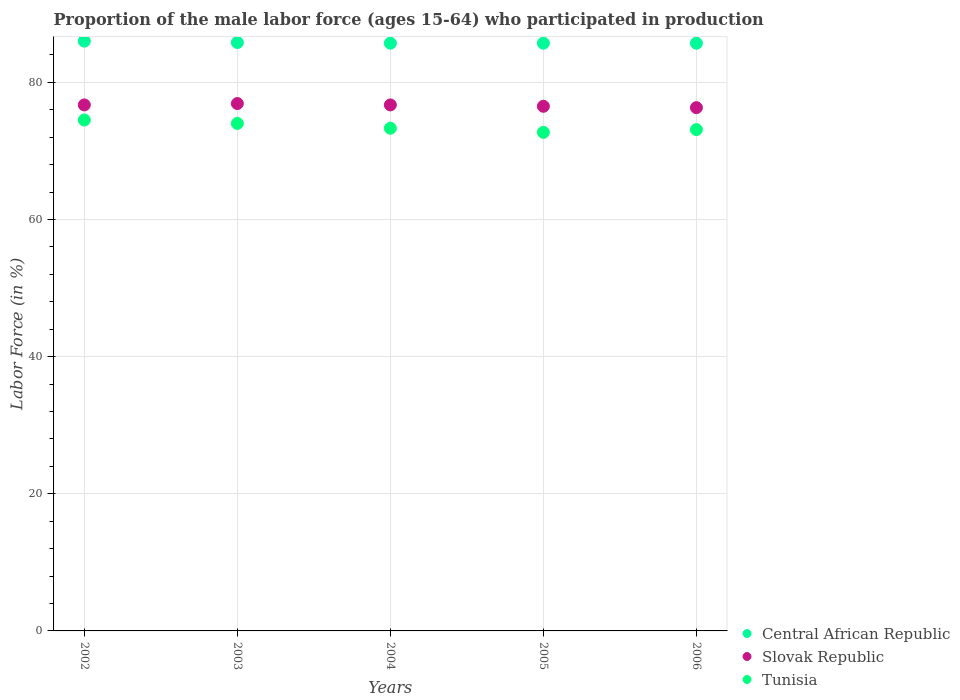Is the number of dotlines equal to the number of legend labels?
Offer a very short reply. Yes. What is the proportion of the male labor force who participated in production in Central African Republic in 2004?
Make the answer very short. 85.7. Across all years, what is the maximum proportion of the male labor force who participated in production in Tunisia?
Give a very brief answer. 74.5. Across all years, what is the minimum proportion of the male labor force who participated in production in Slovak Republic?
Make the answer very short. 76.3. In which year was the proportion of the male labor force who participated in production in Slovak Republic maximum?
Your response must be concise. 2003. What is the total proportion of the male labor force who participated in production in Central African Republic in the graph?
Give a very brief answer. 428.9. What is the difference between the proportion of the male labor force who participated in production in Slovak Republic in 2003 and that in 2005?
Offer a terse response. 0.4. What is the difference between the proportion of the male labor force who participated in production in Tunisia in 2003 and the proportion of the male labor force who participated in production in Central African Republic in 2005?
Your response must be concise. -11.7. What is the average proportion of the male labor force who participated in production in Slovak Republic per year?
Make the answer very short. 76.62. In the year 2006, what is the difference between the proportion of the male labor force who participated in production in Central African Republic and proportion of the male labor force who participated in production in Tunisia?
Offer a terse response. 12.6. What is the ratio of the proportion of the male labor force who participated in production in Slovak Republic in 2004 to that in 2006?
Keep it short and to the point. 1.01. Is the proportion of the male labor force who participated in production in Slovak Republic in 2002 less than that in 2004?
Provide a short and direct response. No. What is the difference between the highest and the second highest proportion of the male labor force who participated in production in Slovak Republic?
Keep it short and to the point. 0.2. What is the difference between the highest and the lowest proportion of the male labor force who participated in production in Tunisia?
Offer a terse response. 1.8. Is the proportion of the male labor force who participated in production in Slovak Republic strictly greater than the proportion of the male labor force who participated in production in Tunisia over the years?
Your answer should be compact. Yes. How many dotlines are there?
Make the answer very short. 3. What is the difference between two consecutive major ticks on the Y-axis?
Your response must be concise. 20. Are the values on the major ticks of Y-axis written in scientific E-notation?
Your response must be concise. No. Where does the legend appear in the graph?
Your response must be concise. Bottom right. What is the title of the graph?
Your answer should be very brief. Proportion of the male labor force (ages 15-64) who participated in production. What is the label or title of the X-axis?
Your answer should be compact. Years. What is the label or title of the Y-axis?
Your answer should be compact. Labor Force (in %). What is the Labor Force (in %) in Slovak Republic in 2002?
Offer a terse response. 76.7. What is the Labor Force (in %) of Tunisia in 2002?
Provide a succinct answer. 74.5. What is the Labor Force (in %) of Central African Republic in 2003?
Make the answer very short. 85.8. What is the Labor Force (in %) of Slovak Republic in 2003?
Give a very brief answer. 76.9. What is the Labor Force (in %) in Central African Republic in 2004?
Provide a short and direct response. 85.7. What is the Labor Force (in %) in Slovak Republic in 2004?
Your response must be concise. 76.7. What is the Labor Force (in %) of Tunisia in 2004?
Give a very brief answer. 73.3. What is the Labor Force (in %) in Central African Republic in 2005?
Give a very brief answer. 85.7. What is the Labor Force (in %) in Slovak Republic in 2005?
Offer a very short reply. 76.5. What is the Labor Force (in %) of Tunisia in 2005?
Provide a short and direct response. 72.7. What is the Labor Force (in %) in Central African Republic in 2006?
Your response must be concise. 85.7. What is the Labor Force (in %) of Slovak Republic in 2006?
Ensure brevity in your answer.  76.3. What is the Labor Force (in %) in Tunisia in 2006?
Offer a terse response. 73.1. Across all years, what is the maximum Labor Force (in %) of Central African Republic?
Offer a terse response. 86. Across all years, what is the maximum Labor Force (in %) in Slovak Republic?
Your answer should be very brief. 76.9. Across all years, what is the maximum Labor Force (in %) of Tunisia?
Keep it short and to the point. 74.5. Across all years, what is the minimum Labor Force (in %) of Central African Republic?
Your response must be concise. 85.7. Across all years, what is the minimum Labor Force (in %) of Slovak Republic?
Offer a very short reply. 76.3. Across all years, what is the minimum Labor Force (in %) of Tunisia?
Your answer should be compact. 72.7. What is the total Labor Force (in %) of Central African Republic in the graph?
Offer a very short reply. 428.9. What is the total Labor Force (in %) in Slovak Republic in the graph?
Your response must be concise. 383.1. What is the total Labor Force (in %) of Tunisia in the graph?
Keep it short and to the point. 367.6. What is the difference between the Labor Force (in %) in Central African Republic in 2002 and that in 2003?
Offer a terse response. 0.2. What is the difference between the Labor Force (in %) of Slovak Republic in 2002 and that in 2003?
Make the answer very short. -0.2. What is the difference between the Labor Force (in %) in Tunisia in 2002 and that in 2004?
Your answer should be very brief. 1.2. What is the difference between the Labor Force (in %) in Slovak Republic in 2002 and that in 2006?
Give a very brief answer. 0.4. What is the difference between the Labor Force (in %) in Central African Republic in 2003 and that in 2004?
Provide a short and direct response. 0.1. What is the difference between the Labor Force (in %) of Slovak Republic in 2003 and that in 2004?
Provide a short and direct response. 0.2. What is the difference between the Labor Force (in %) of Tunisia in 2003 and that in 2004?
Provide a succinct answer. 0.7. What is the difference between the Labor Force (in %) of Central African Republic in 2003 and that in 2005?
Offer a very short reply. 0.1. What is the difference between the Labor Force (in %) of Slovak Republic in 2003 and that in 2005?
Your answer should be very brief. 0.4. What is the difference between the Labor Force (in %) of Tunisia in 2003 and that in 2005?
Your response must be concise. 1.3. What is the difference between the Labor Force (in %) in Central African Republic in 2003 and that in 2006?
Keep it short and to the point. 0.1. What is the difference between the Labor Force (in %) in Slovak Republic in 2003 and that in 2006?
Your answer should be very brief. 0.6. What is the difference between the Labor Force (in %) in Tunisia in 2003 and that in 2006?
Offer a terse response. 0.9. What is the difference between the Labor Force (in %) in Slovak Republic in 2004 and that in 2005?
Make the answer very short. 0.2. What is the difference between the Labor Force (in %) in Central African Republic in 2004 and that in 2006?
Ensure brevity in your answer.  0. What is the difference between the Labor Force (in %) of Tunisia in 2004 and that in 2006?
Your answer should be compact. 0.2. What is the difference between the Labor Force (in %) in Central African Republic in 2005 and that in 2006?
Your answer should be compact. 0. What is the difference between the Labor Force (in %) of Slovak Republic in 2005 and that in 2006?
Give a very brief answer. 0.2. What is the difference between the Labor Force (in %) in Central African Republic in 2002 and the Labor Force (in %) in Tunisia in 2003?
Provide a succinct answer. 12. What is the difference between the Labor Force (in %) in Slovak Republic in 2002 and the Labor Force (in %) in Tunisia in 2003?
Make the answer very short. 2.7. What is the difference between the Labor Force (in %) of Central African Republic in 2002 and the Labor Force (in %) of Slovak Republic in 2004?
Your answer should be compact. 9.3. What is the difference between the Labor Force (in %) of Central African Republic in 2002 and the Labor Force (in %) of Tunisia in 2004?
Your answer should be very brief. 12.7. What is the difference between the Labor Force (in %) of Slovak Republic in 2002 and the Labor Force (in %) of Tunisia in 2004?
Offer a terse response. 3.4. What is the difference between the Labor Force (in %) of Central African Republic in 2002 and the Labor Force (in %) of Slovak Republic in 2005?
Your answer should be compact. 9.5. What is the difference between the Labor Force (in %) of Central African Republic in 2002 and the Labor Force (in %) of Tunisia in 2005?
Give a very brief answer. 13.3. What is the difference between the Labor Force (in %) of Slovak Republic in 2002 and the Labor Force (in %) of Tunisia in 2005?
Offer a very short reply. 4. What is the difference between the Labor Force (in %) in Central African Republic in 2003 and the Labor Force (in %) in Tunisia in 2005?
Provide a succinct answer. 13.1. What is the difference between the Labor Force (in %) of Slovak Republic in 2003 and the Labor Force (in %) of Tunisia in 2005?
Your answer should be very brief. 4.2. What is the difference between the Labor Force (in %) of Central African Republic in 2003 and the Labor Force (in %) of Slovak Republic in 2006?
Provide a succinct answer. 9.5. What is the difference between the Labor Force (in %) in Slovak Republic in 2003 and the Labor Force (in %) in Tunisia in 2006?
Offer a terse response. 3.8. What is the difference between the Labor Force (in %) in Slovak Republic in 2004 and the Labor Force (in %) in Tunisia in 2005?
Your answer should be very brief. 4. What is the difference between the Labor Force (in %) of Central African Republic in 2004 and the Labor Force (in %) of Slovak Republic in 2006?
Provide a short and direct response. 9.4. What is the difference between the Labor Force (in %) of Central African Republic in 2004 and the Labor Force (in %) of Tunisia in 2006?
Make the answer very short. 12.6. What is the difference between the Labor Force (in %) of Slovak Republic in 2004 and the Labor Force (in %) of Tunisia in 2006?
Provide a succinct answer. 3.6. What is the difference between the Labor Force (in %) in Central African Republic in 2005 and the Labor Force (in %) in Slovak Republic in 2006?
Provide a succinct answer. 9.4. What is the difference between the Labor Force (in %) of Slovak Republic in 2005 and the Labor Force (in %) of Tunisia in 2006?
Provide a succinct answer. 3.4. What is the average Labor Force (in %) in Central African Republic per year?
Your response must be concise. 85.78. What is the average Labor Force (in %) of Slovak Republic per year?
Offer a terse response. 76.62. What is the average Labor Force (in %) of Tunisia per year?
Keep it short and to the point. 73.52. In the year 2002, what is the difference between the Labor Force (in %) in Central African Republic and Labor Force (in %) in Slovak Republic?
Your response must be concise. 9.3. In the year 2002, what is the difference between the Labor Force (in %) of Slovak Republic and Labor Force (in %) of Tunisia?
Your response must be concise. 2.2. In the year 2003, what is the difference between the Labor Force (in %) of Slovak Republic and Labor Force (in %) of Tunisia?
Offer a terse response. 2.9. In the year 2004, what is the difference between the Labor Force (in %) of Slovak Republic and Labor Force (in %) of Tunisia?
Provide a succinct answer. 3.4. In the year 2005, what is the difference between the Labor Force (in %) of Central African Republic and Labor Force (in %) of Tunisia?
Offer a very short reply. 13. In the year 2006, what is the difference between the Labor Force (in %) in Central African Republic and Labor Force (in %) in Slovak Republic?
Keep it short and to the point. 9.4. In the year 2006, what is the difference between the Labor Force (in %) in Central African Republic and Labor Force (in %) in Tunisia?
Offer a terse response. 12.6. In the year 2006, what is the difference between the Labor Force (in %) of Slovak Republic and Labor Force (in %) of Tunisia?
Your answer should be very brief. 3.2. What is the ratio of the Labor Force (in %) of Tunisia in 2002 to that in 2003?
Provide a succinct answer. 1.01. What is the ratio of the Labor Force (in %) in Central African Republic in 2002 to that in 2004?
Your response must be concise. 1. What is the ratio of the Labor Force (in %) in Tunisia in 2002 to that in 2004?
Make the answer very short. 1.02. What is the ratio of the Labor Force (in %) in Central African Republic in 2002 to that in 2005?
Give a very brief answer. 1. What is the ratio of the Labor Force (in %) in Slovak Republic in 2002 to that in 2005?
Offer a terse response. 1. What is the ratio of the Labor Force (in %) in Tunisia in 2002 to that in 2005?
Provide a short and direct response. 1.02. What is the ratio of the Labor Force (in %) in Slovak Republic in 2002 to that in 2006?
Your response must be concise. 1.01. What is the ratio of the Labor Force (in %) of Tunisia in 2002 to that in 2006?
Make the answer very short. 1.02. What is the ratio of the Labor Force (in %) of Central African Republic in 2003 to that in 2004?
Provide a short and direct response. 1. What is the ratio of the Labor Force (in %) of Slovak Republic in 2003 to that in 2004?
Offer a very short reply. 1. What is the ratio of the Labor Force (in %) of Tunisia in 2003 to that in 2004?
Keep it short and to the point. 1.01. What is the ratio of the Labor Force (in %) in Tunisia in 2003 to that in 2005?
Give a very brief answer. 1.02. What is the ratio of the Labor Force (in %) of Slovak Republic in 2003 to that in 2006?
Provide a succinct answer. 1.01. What is the ratio of the Labor Force (in %) in Tunisia in 2003 to that in 2006?
Make the answer very short. 1.01. What is the ratio of the Labor Force (in %) of Tunisia in 2004 to that in 2005?
Ensure brevity in your answer.  1.01. What is the ratio of the Labor Force (in %) in Tunisia in 2004 to that in 2006?
Make the answer very short. 1. What is the difference between the highest and the second highest Labor Force (in %) of Tunisia?
Offer a terse response. 0.5. What is the difference between the highest and the lowest Labor Force (in %) in Central African Republic?
Give a very brief answer. 0.3. What is the difference between the highest and the lowest Labor Force (in %) in Slovak Republic?
Provide a short and direct response. 0.6. 